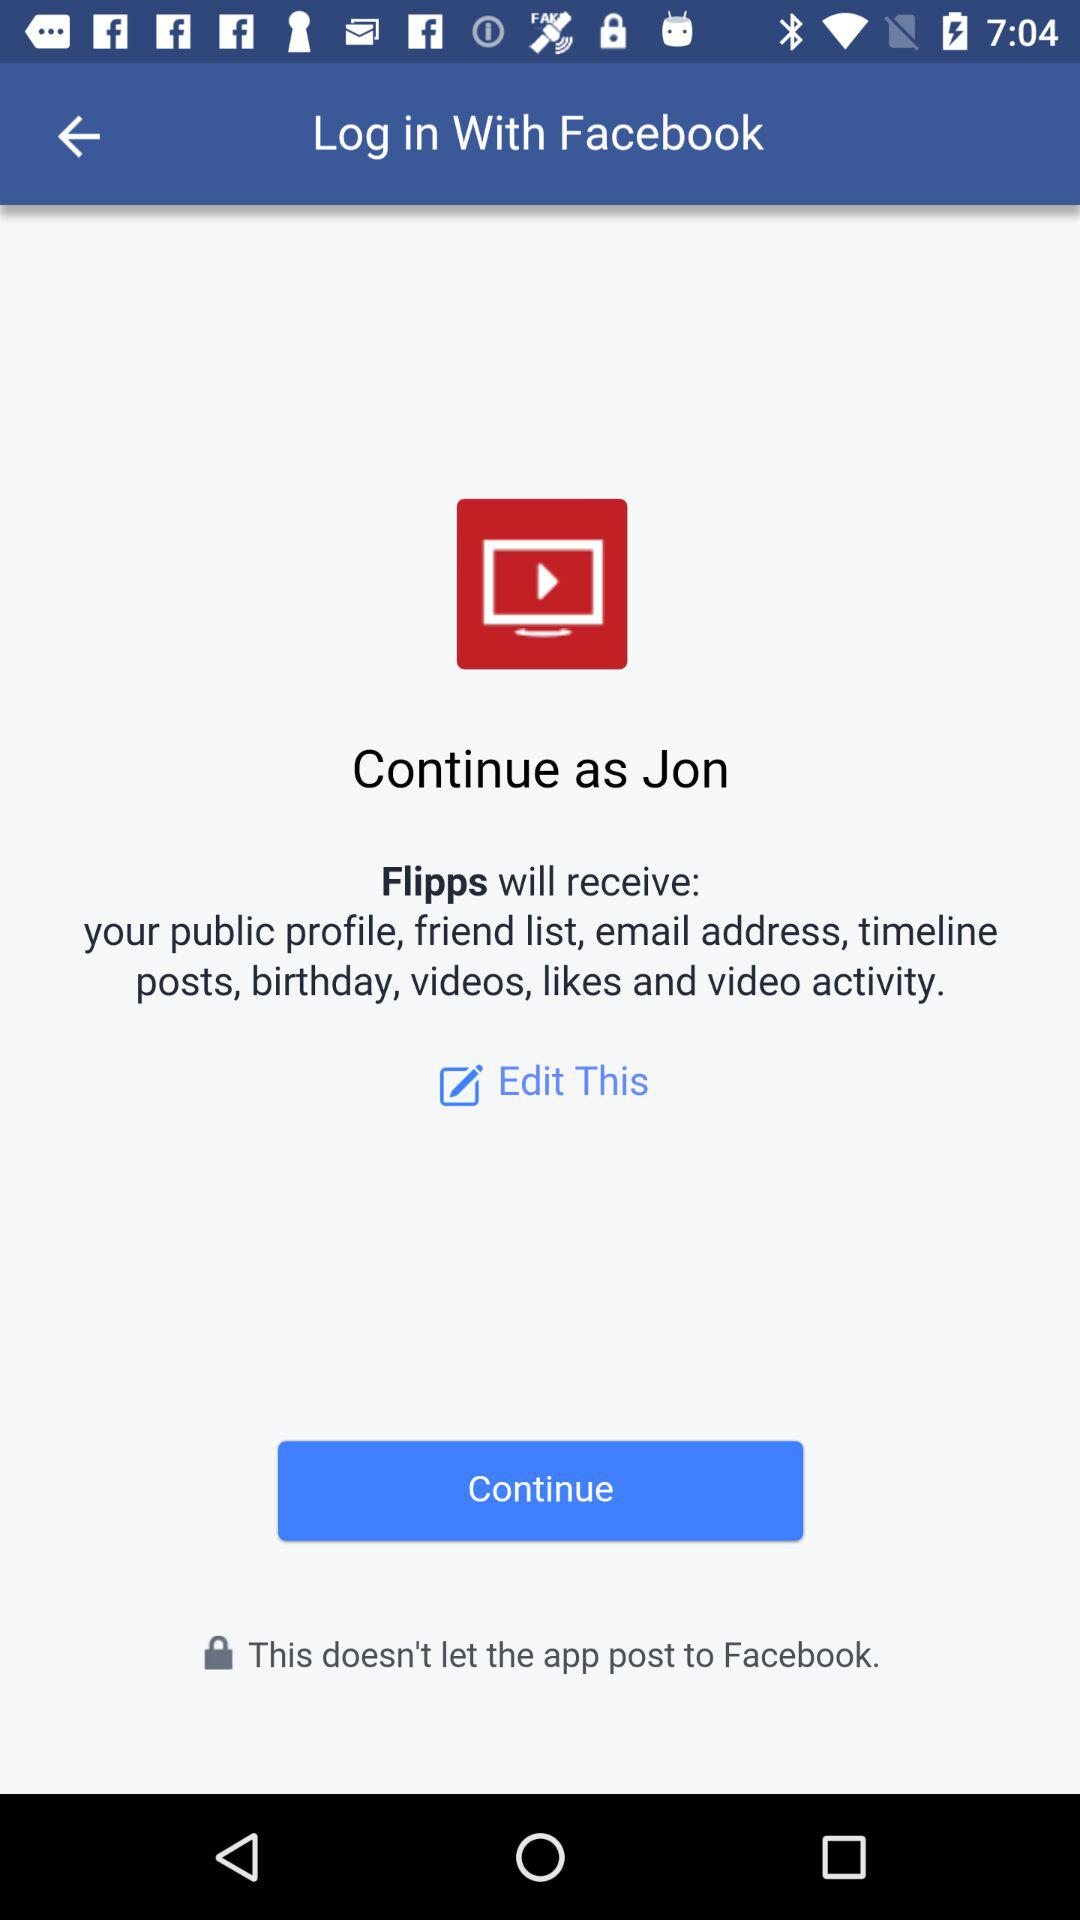What is the name of the user? The user name is Jon. 